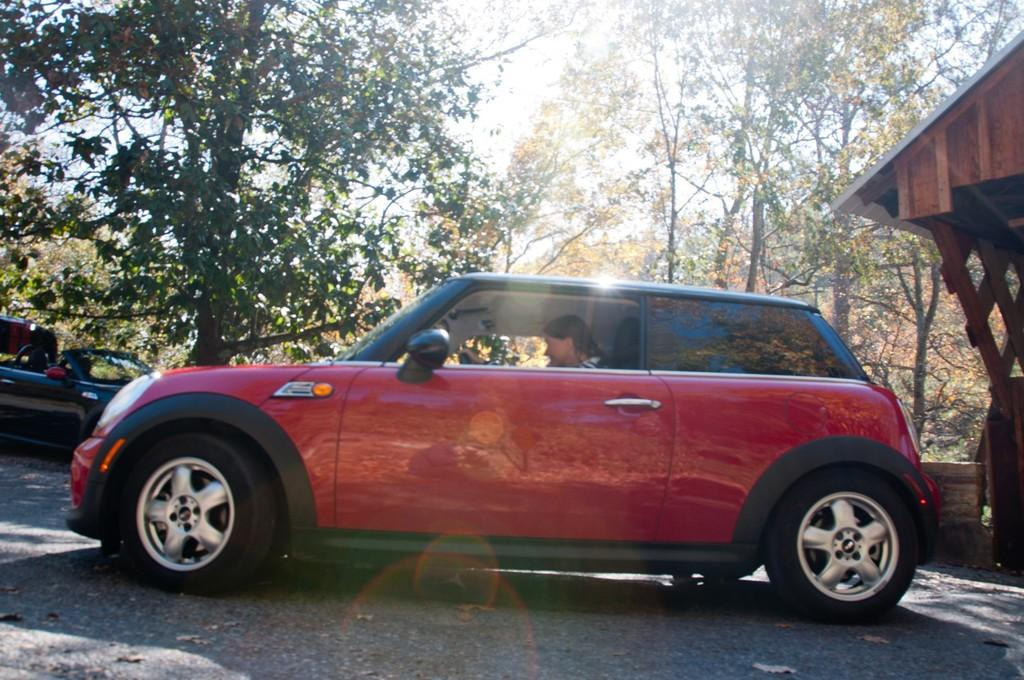Who is present in the image? There is a woman in the image. What is the woman doing in the image? The woman is sitting in a small red color car and driving it. Where is the car located in the image? The car is on the road. What can be seen in the background of the image? There are trees visible in the background. What type of vegetable is the woman holding in the image? There is no vegetable present in the image; the woman is driving a car. 